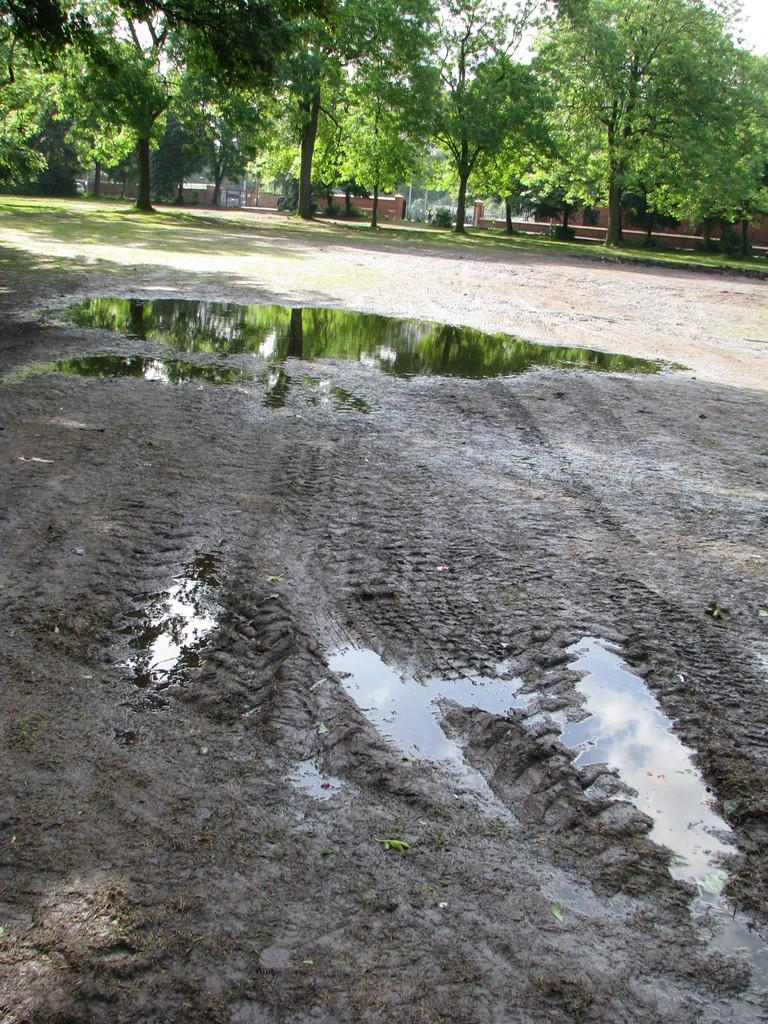What type of natural elements can be seen in the background of the image? There are trees in the background of the image. What type of man-made structures are visible in the background of the image? There are houses in the background of the image. What is located at the bottom of the image? There is a road at the bottom of the image. What type of terrain is visible at the bottom of the image? There is water visible at the bottom of the image. What grade is the student writing in the image? There is no student or writing present in the image. What type of cable is visible in the image? There is: There is no cable visible in the image. 